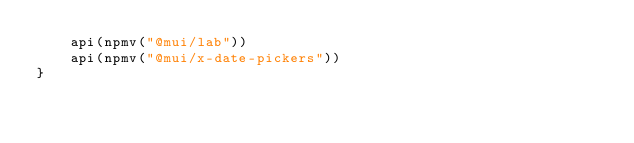<code> <loc_0><loc_0><loc_500><loc_500><_Kotlin_>    api(npmv("@mui/lab"))
    api(npmv("@mui/x-date-pickers"))
}
</code> 